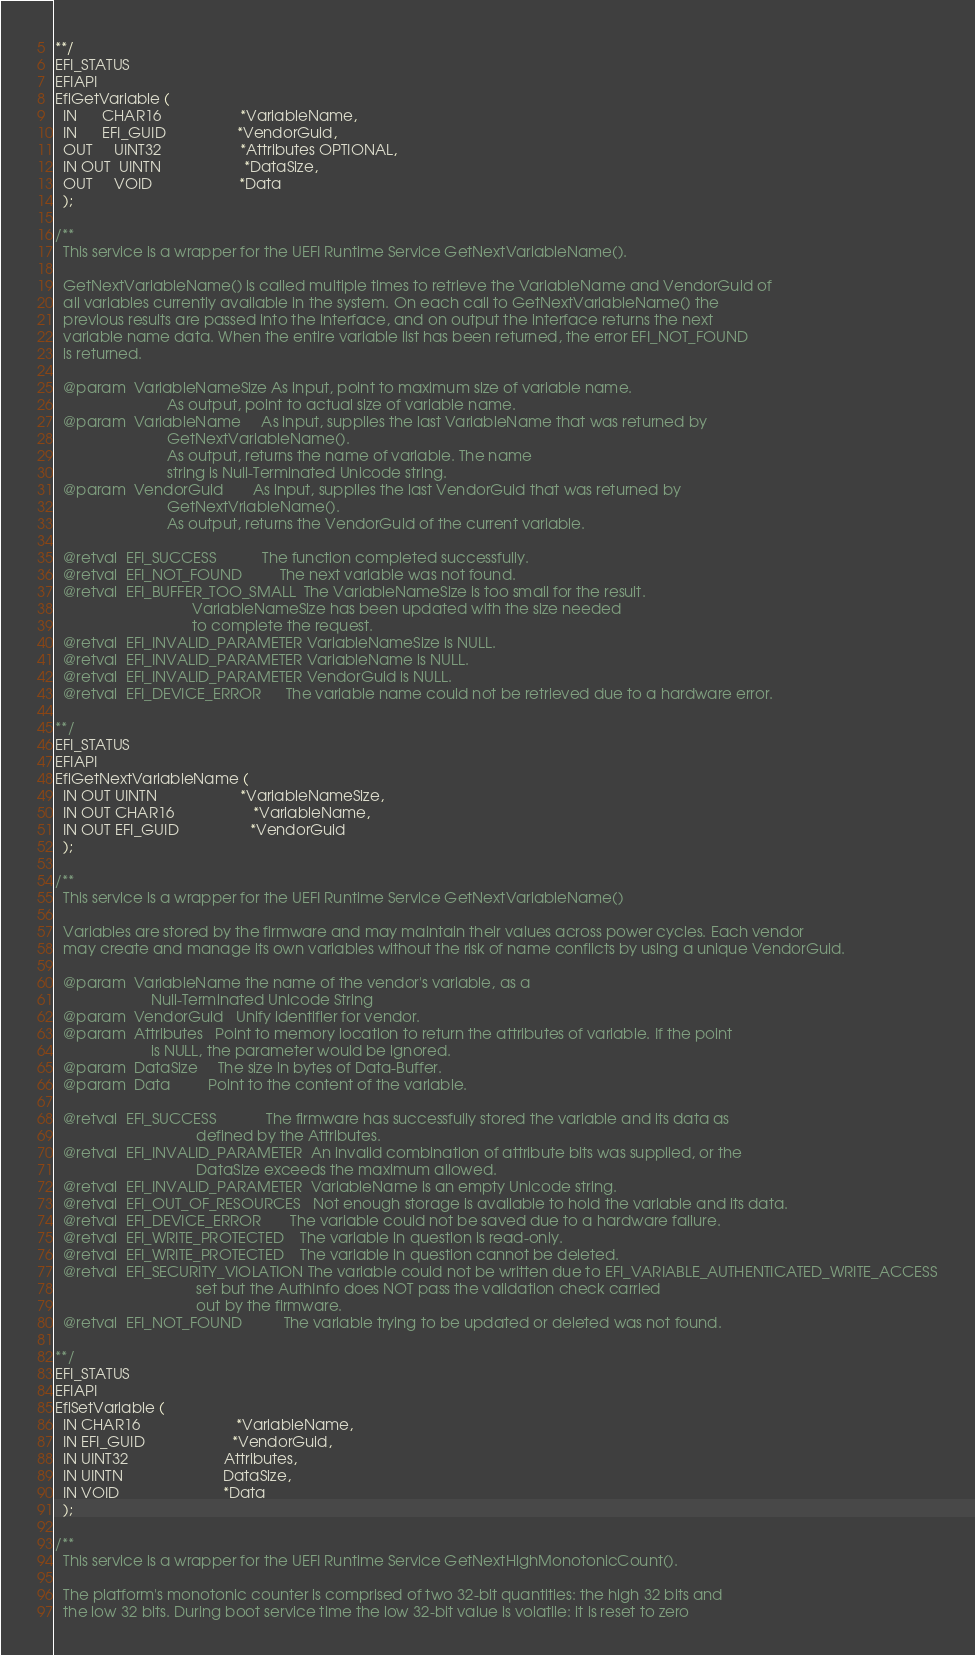Convert code to text. <code><loc_0><loc_0><loc_500><loc_500><_C_>**/
EFI_STATUS
EFIAPI
EfiGetVariable (
  IN      CHAR16                   *VariableName,
  IN      EFI_GUID                 *VendorGuid,
  OUT     UINT32                   *Attributes OPTIONAL,
  IN OUT  UINTN                    *DataSize,
  OUT     VOID                     *Data
  );

/**
  This service is a wrapper for the UEFI Runtime Service GetNextVariableName().

  GetNextVariableName() is called multiple times to retrieve the VariableName and VendorGuid of
  all variables currently available in the system. On each call to GetNextVariableName() the
  previous results are passed into the interface, and on output the interface returns the next
  variable name data. When the entire variable list has been returned, the error EFI_NOT_FOUND
  is returned.

  @param  VariableNameSize As input, point to maximum size of variable name.
                           As output, point to actual size of variable name.
  @param  VariableName     As input, supplies the last VariableName that was returned by
                           GetNextVariableName().
                           As output, returns the name of variable. The name
                           string is Null-Terminated Unicode string.
  @param  VendorGuid       As input, supplies the last VendorGuid that was returned by
                           GetNextVriableName().
                           As output, returns the VendorGuid of the current variable.

  @retval  EFI_SUCCESS           The function completed successfully.
  @retval  EFI_NOT_FOUND         The next variable was not found.
  @retval  EFI_BUFFER_TOO_SMALL  The VariableNameSize is too small for the result.
                                 VariableNameSize has been updated with the size needed
                                 to complete the request.
  @retval  EFI_INVALID_PARAMETER VariableNameSize is NULL.
  @retval  EFI_INVALID_PARAMETER VariableName is NULL.
  @retval  EFI_INVALID_PARAMETER VendorGuid is NULL.
  @retval  EFI_DEVICE_ERROR      The variable name could not be retrieved due to a hardware error.

**/
EFI_STATUS
EFIAPI
EfiGetNextVariableName (
  IN OUT UINTN                    *VariableNameSize,
  IN OUT CHAR16                   *VariableName,
  IN OUT EFI_GUID                 *VendorGuid
  );

/**
  This service is a wrapper for the UEFI Runtime Service GetNextVariableName()

  Variables are stored by the firmware and may maintain their values across power cycles. Each vendor
  may create and manage its own variables without the risk of name conflicts by using a unique VendorGuid.

  @param  VariableName the name of the vendor's variable, as a
                       Null-Terminated Unicode String
  @param  VendorGuid   Unify identifier for vendor.
  @param  Attributes   Point to memory location to return the attributes of variable. If the point
                       is NULL, the parameter would be ignored.
  @param  DataSize     The size in bytes of Data-Buffer.
  @param  Data         Point to the content of the variable.

  @retval  EFI_SUCCESS            The firmware has successfully stored the variable and its data as
                                  defined by the Attributes.
  @retval  EFI_INVALID_PARAMETER  An invalid combination of attribute bits was supplied, or the
                                  DataSize exceeds the maximum allowed.
  @retval  EFI_INVALID_PARAMETER  VariableName is an empty Unicode string.
  @retval  EFI_OUT_OF_RESOURCES   Not enough storage is available to hold the variable and its data.
  @retval  EFI_DEVICE_ERROR       The variable could not be saved due to a hardware failure.
  @retval  EFI_WRITE_PROTECTED    The variable in question is read-only.
  @retval  EFI_WRITE_PROTECTED    The variable in question cannot be deleted.
  @retval  EFI_SECURITY_VIOLATION The variable could not be written due to EFI_VARIABLE_AUTHENTICATED_WRITE_ACCESS
                                  set but the AuthInfo does NOT pass the validation check carried
                                  out by the firmware.
  @retval  EFI_NOT_FOUND          The variable trying to be updated or deleted was not found.

**/
EFI_STATUS
EFIAPI
EfiSetVariable (
  IN CHAR16                       *VariableName,
  IN EFI_GUID                     *VendorGuid,
  IN UINT32                       Attributes,
  IN UINTN                        DataSize,
  IN VOID                         *Data
  );

/**
  This service is a wrapper for the UEFI Runtime Service GetNextHighMonotonicCount().

  The platform's monotonic counter is comprised of two 32-bit quantities: the high 32 bits and
  the low 32 bits. During boot service time the low 32-bit value is volatile: it is reset to zero</code> 